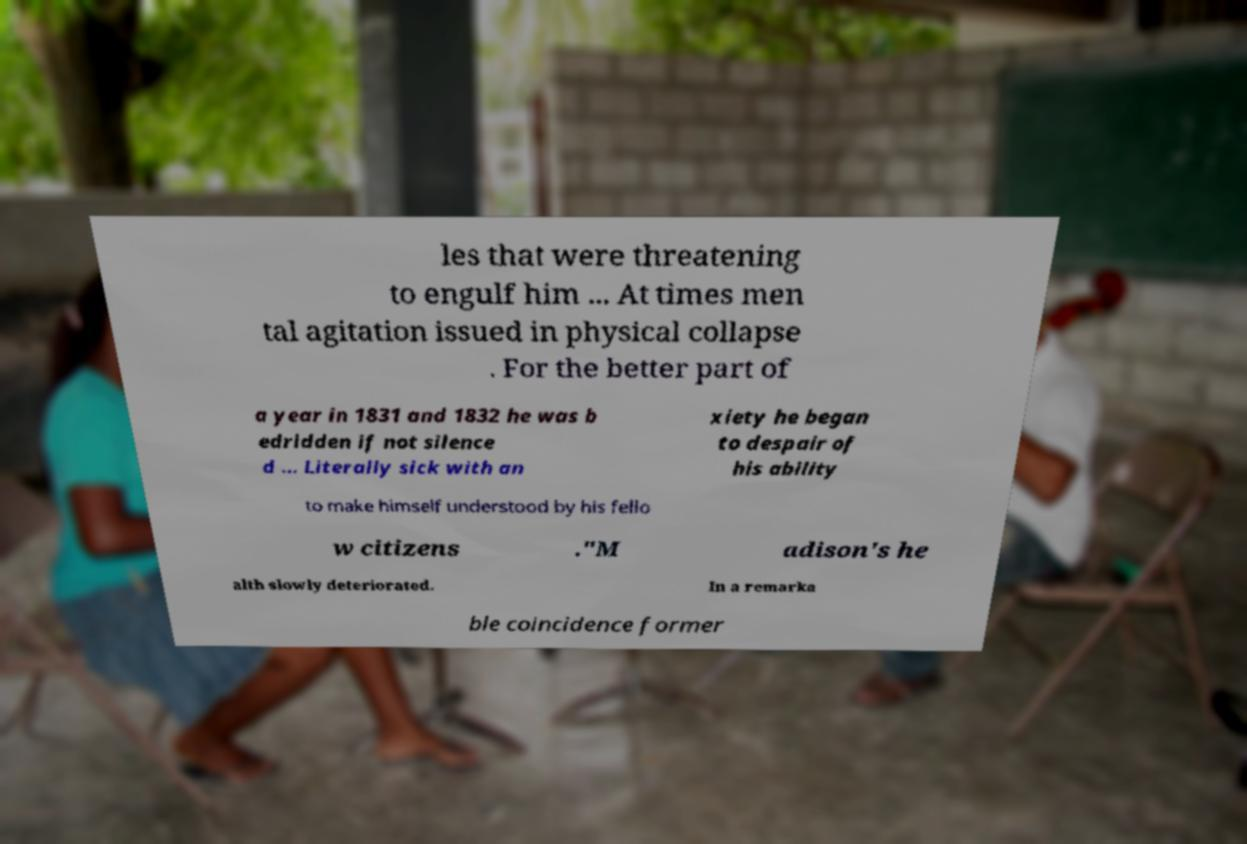Please identify and transcribe the text found in this image. les that were threatening to engulf him ... At times men tal agitation issued in physical collapse . For the better part of a year in 1831 and 1832 he was b edridden if not silence d ... Literally sick with an xiety he began to despair of his ability to make himself understood by his fello w citizens ."M adison's he alth slowly deteriorated. In a remarka ble coincidence former 